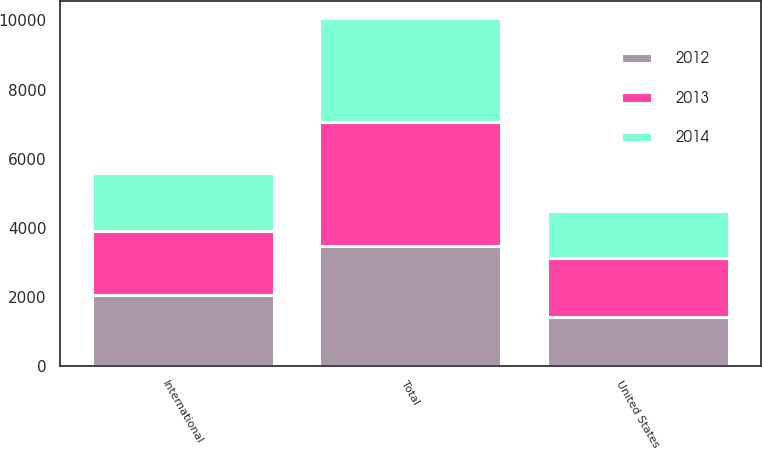Convert chart to OTSL. <chart><loc_0><loc_0><loc_500><loc_500><stacked_bar_chart><ecel><fcel>United States<fcel>International<fcel>Total<nl><fcel>2012<fcel>1420.9<fcel>2060.9<fcel>3481.8<nl><fcel>2013<fcel>1713.7<fcel>1852.3<fcel>3566<nl><fcel>2014<fcel>1349.9<fcel>1660.9<fcel>3010.8<nl></chart> 